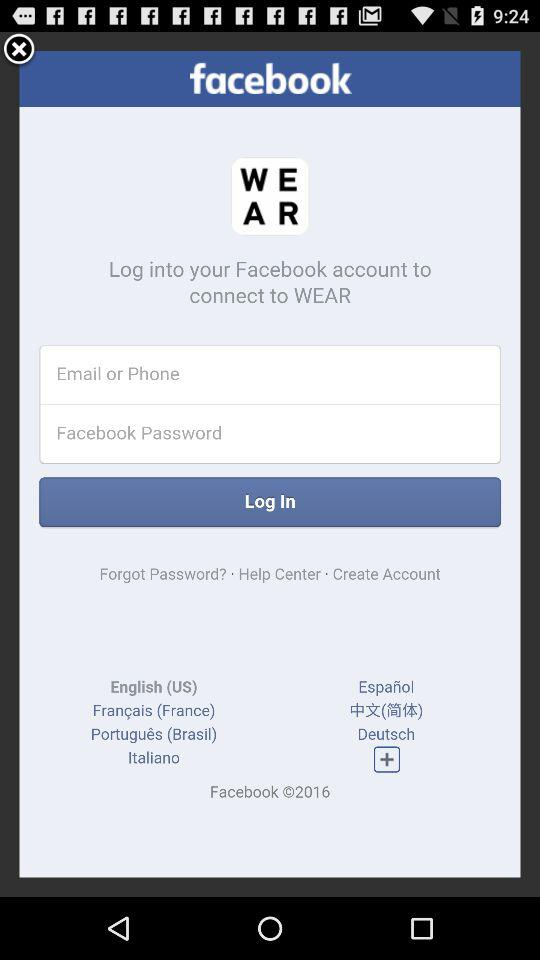Through what application can a user log in with? You can login with "Facebook". 